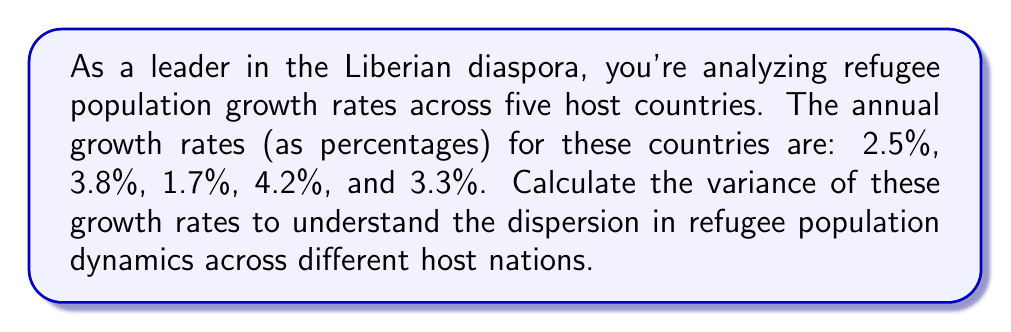Help me with this question. To calculate the variance, we'll follow these steps:

1. Calculate the mean (average) of the growth rates:
   $$\bar{x} = \frac{2.5 + 3.8 + 1.7 + 4.2 + 3.3}{5} = 3.1\%$$

2. Calculate the squared differences from the mean:
   $$(2.5 - 3.1)^2 = (-0.6)^2 = 0.36$$
   $$(3.8 - 3.1)^2 = (0.7)^2 = 0.49$$
   $$(1.7 - 3.1)^2 = (-1.4)^2 = 1.96$$
   $$(4.2 - 3.1)^2 = (1.1)^2 = 1.21$$
   $$(3.3 - 3.1)^2 = (0.2)^2 = 0.04$$

3. Sum the squared differences:
   $$0.36 + 0.49 + 1.96 + 1.21 + 0.04 = 4.06$$

4. Divide by $(n-1) = 4$ to get the variance:
   $$\text{Variance} = \frac{4.06}{4} = 1.015$$

Therefore, the variance of the refugee population growth rates is 1.015 (percentage points squared).
Answer: 1.015 (percentage points squared) 